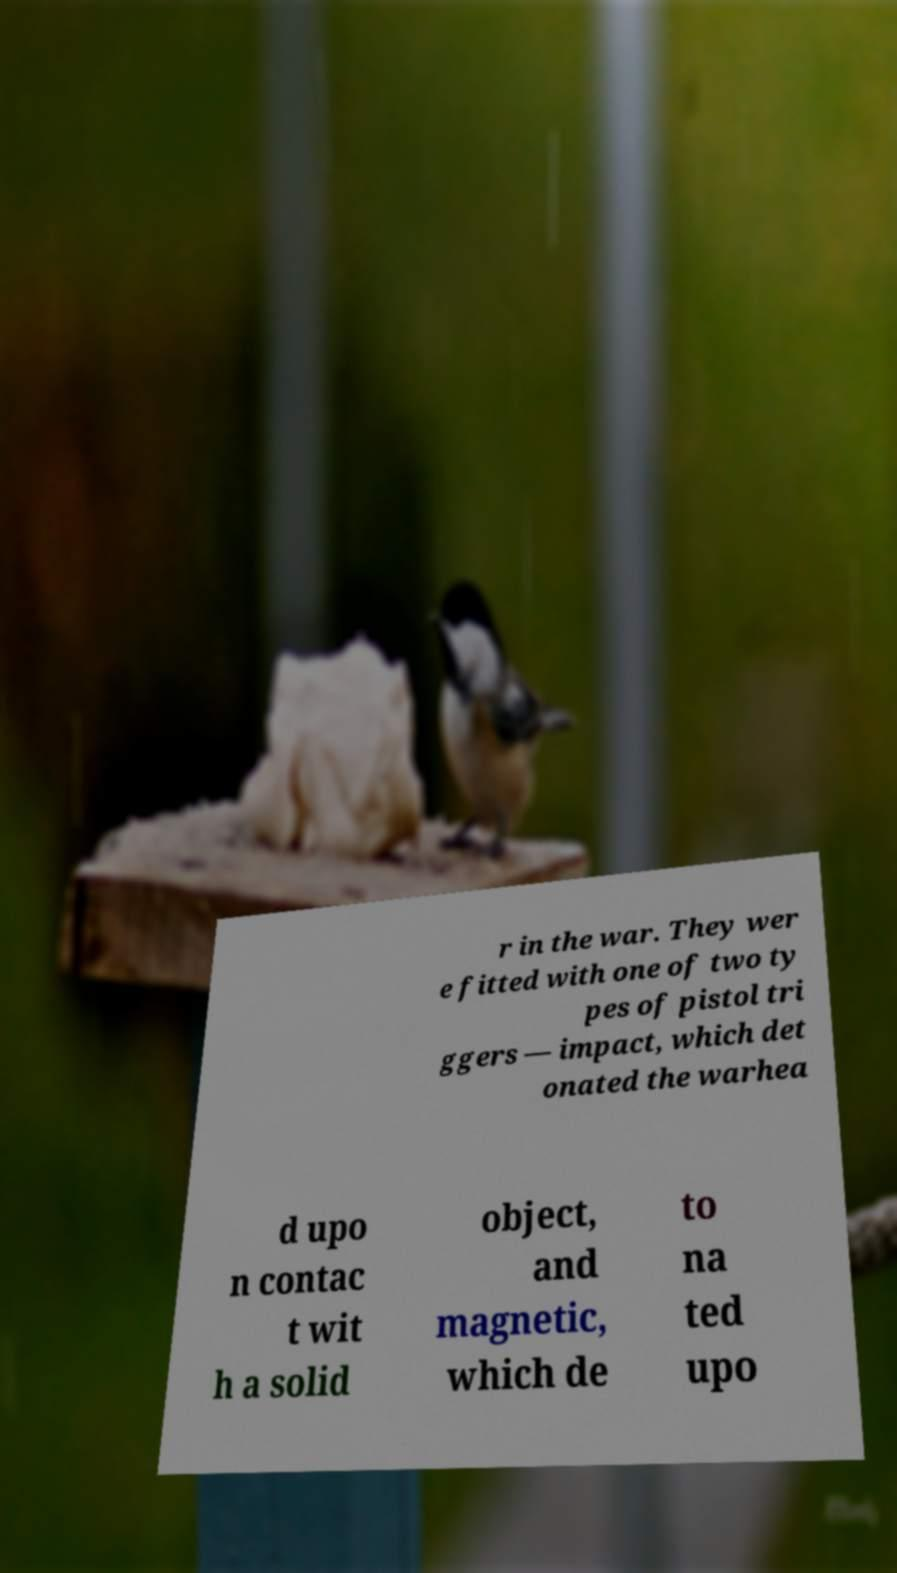Can you accurately transcribe the text from the provided image for me? r in the war. They wer e fitted with one of two ty pes of pistol tri ggers — impact, which det onated the warhea d upo n contac t wit h a solid object, and magnetic, which de to na ted upo 